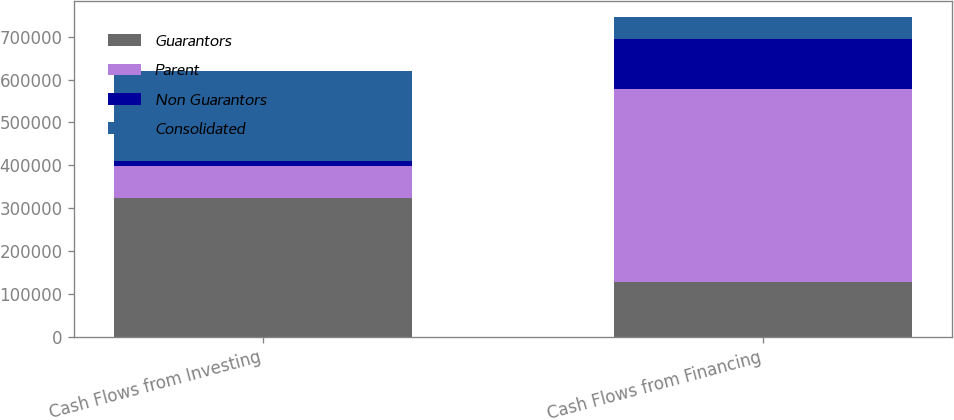Convert chart. <chart><loc_0><loc_0><loc_500><loc_500><stacked_bar_chart><ecel><fcel>Cash Flows from Investing<fcel>Cash Flows from Financing<nl><fcel>Guarantors<fcel>323902<fcel>126873<nl><fcel>Parent<fcel>74968<fcel>451083<nl><fcel>Non Guarantors<fcel>10207<fcel>115922<nl><fcel>Consolidated<fcel>212177<fcel>53142<nl></chart> 